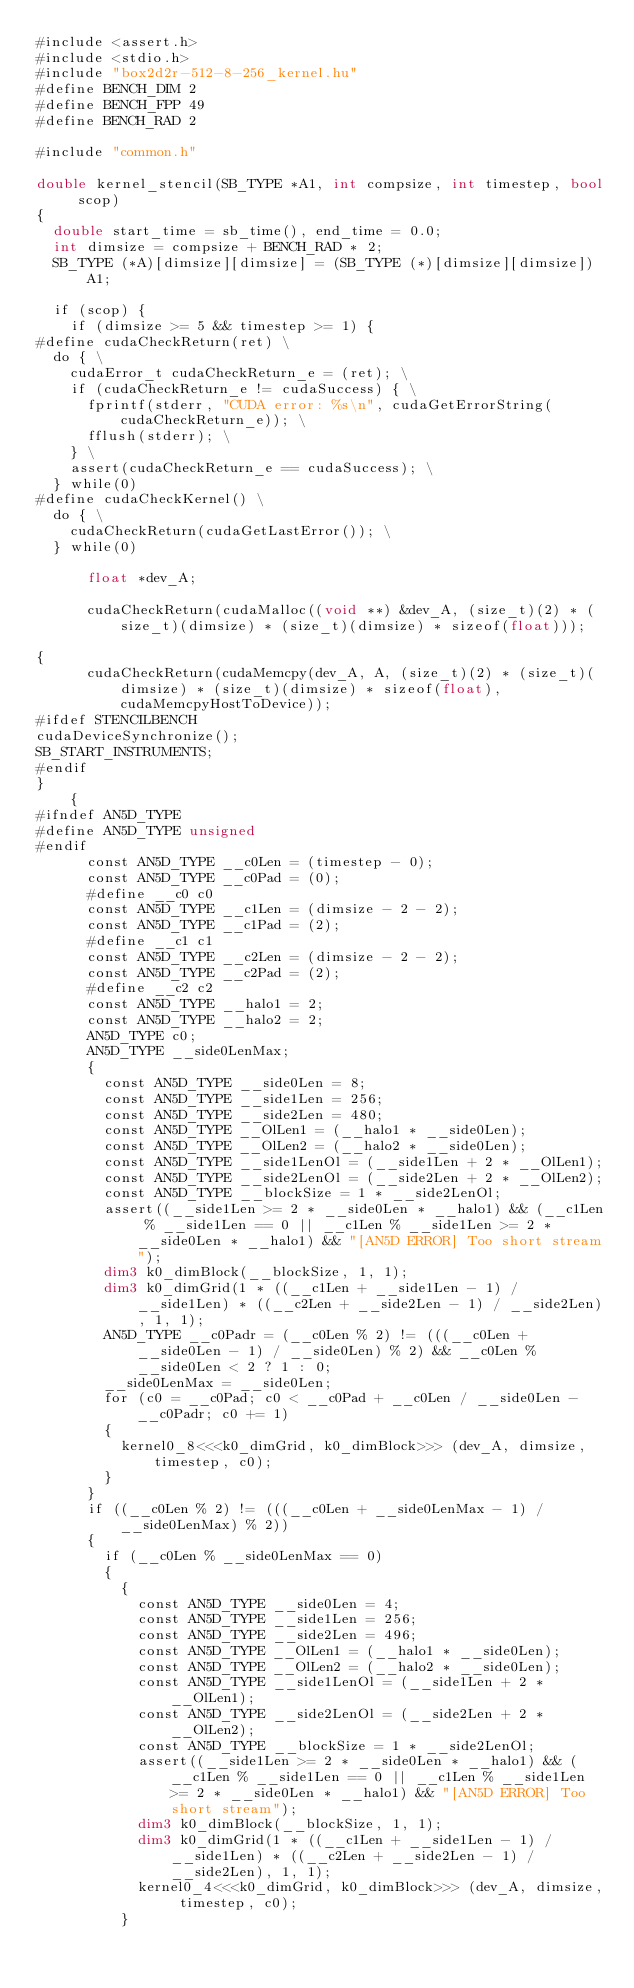<code> <loc_0><loc_0><loc_500><loc_500><_Cuda_>#include <assert.h>
#include <stdio.h>
#include "box2d2r-512-8-256_kernel.hu"
#define BENCH_DIM 2
#define BENCH_FPP 49
#define BENCH_RAD 2

#include "common.h"

double kernel_stencil(SB_TYPE *A1, int compsize, int timestep, bool scop)
{
  double start_time = sb_time(), end_time = 0.0;
  int dimsize = compsize + BENCH_RAD * 2;
  SB_TYPE (*A)[dimsize][dimsize] = (SB_TYPE (*)[dimsize][dimsize])A1;

  if (scop) {
    if (dimsize >= 5 && timestep >= 1) {
#define cudaCheckReturn(ret) \
  do { \
    cudaError_t cudaCheckReturn_e = (ret); \
    if (cudaCheckReturn_e != cudaSuccess) { \
      fprintf(stderr, "CUDA error: %s\n", cudaGetErrorString(cudaCheckReturn_e)); \
      fflush(stderr); \
    } \
    assert(cudaCheckReturn_e == cudaSuccess); \
  } while(0)
#define cudaCheckKernel() \
  do { \
    cudaCheckReturn(cudaGetLastError()); \
  } while(0)

      float *dev_A;
      
      cudaCheckReturn(cudaMalloc((void **) &dev_A, (size_t)(2) * (size_t)(dimsize) * (size_t)(dimsize) * sizeof(float)));
      
{
      cudaCheckReturn(cudaMemcpy(dev_A, A, (size_t)(2) * (size_t)(dimsize) * (size_t)(dimsize) * sizeof(float), cudaMemcpyHostToDevice));
#ifdef STENCILBENCH
cudaDeviceSynchronize();
SB_START_INSTRUMENTS;
#endif
}
    {
#ifndef AN5D_TYPE
#define AN5D_TYPE unsigned
#endif
      const AN5D_TYPE __c0Len = (timestep - 0);
      const AN5D_TYPE __c0Pad = (0);
      #define __c0 c0
      const AN5D_TYPE __c1Len = (dimsize - 2 - 2);
      const AN5D_TYPE __c1Pad = (2);
      #define __c1 c1
      const AN5D_TYPE __c2Len = (dimsize - 2 - 2);
      const AN5D_TYPE __c2Pad = (2);
      #define __c2 c2
      const AN5D_TYPE __halo1 = 2;
      const AN5D_TYPE __halo2 = 2;
      AN5D_TYPE c0;
      AN5D_TYPE __side0LenMax;
      {
        const AN5D_TYPE __side0Len = 8;
        const AN5D_TYPE __side1Len = 256;
        const AN5D_TYPE __side2Len = 480;
        const AN5D_TYPE __OlLen1 = (__halo1 * __side0Len);
        const AN5D_TYPE __OlLen2 = (__halo2 * __side0Len);
        const AN5D_TYPE __side1LenOl = (__side1Len + 2 * __OlLen1);
        const AN5D_TYPE __side2LenOl = (__side2Len + 2 * __OlLen2);
        const AN5D_TYPE __blockSize = 1 * __side2LenOl;
        assert((__side1Len >= 2 * __side0Len * __halo1) && (__c1Len % __side1Len == 0 || __c1Len % __side1Len >= 2 * __side0Len * __halo1) && "[AN5D ERROR] Too short stream");
        dim3 k0_dimBlock(__blockSize, 1, 1);
        dim3 k0_dimGrid(1 * ((__c1Len + __side1Len - 1) / __side1Len) * ((__c2Len + __side2Len - 1) / __side2Len), 1, 1);
        AN5D_TYPE __c0Padr = (__c0Len % 2) != (((__c0Len + __side0Len - 1) / __side0Len) % 2) && __c0Len % __side0Len < 2 ? 1 : 0;
        __side0LenMax = __side0Len;
        for (c0 = __c0Pad; c0 < __c0Pad + __c0Len / __side0Len - __c0Padr; c0 += 1)
        {
          kernel0_8<<<k0_dimGrid, k0_dimBlock>>> (dev_A, dimsize, timestep, c0);
        }
      }
      if ((__c0Len % 2) != (((__c0Len + __side0LenMax - 1) / __side0LenMax) % 2))
      {
        if (__c0Len % __side0LenMax == 0)
        {
          {
            const AN5D_TYPE __side0Len = 4;
            const AN5D_TYPE __side1Len = 256;
            const AN5D_TYPE __side2Len = 496;
            const AN5D_TYPE __OlLen1 = (__halo1 * __side0Len);
            const AN5D_TYPE __OlLen2 = (__halo2 * __side0Len);
            const AN5D_TYPE __side1LenOl = (__side1Len + 2 * __OlLen1);
            const AN5D_TYPE __side2LenOl = (__side2Len + 2 * __OlLen2);
            const AN5D_TYPE __blockSize = 1 * __side2LenOl;
            assert((__side1Len >= 2 * __side0Len * __halo1) && (__c1Len % __side1Len == 0 || __c1Len % __side1Len >= 2 * __side0Len * __halo1) && "[AN5D ERROR] Too short stream");
            dim3 k0_dimBlock(__blockSize, 1, 1);
            dim3 k0_dimGrid(1 * ((__c1Len + __side1Len - 1) / __side1Len) * ((__c2Len + __side2Len - 1) / __side2Len), 1, 1);
            kernel0_4<<<k0_dimGrid, k0_dimBlock>>> (dev_A, dimsize, timestep, c0);
          }</code> 